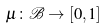Convert formula to latex. <formula><loc_0><loc_0><loc_500><loc_500>\mu \colon { \mathcal { B } } \rightarrow [ 0 , 1 ]</formula> 